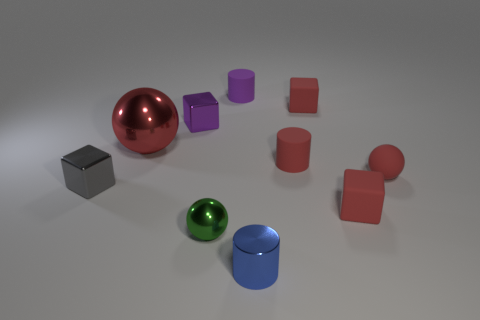How big is the green shiny thing that is on the left side of the rubber object in front of the small gray block?
Offer a very short reply. Small. There is a thing that is on the right side of the small rubber cube in front of the matte cube that is behind the red shiny sphere; what is its size?
Your response must be concise. Small. There is a tiny red thing that is in front of the small gray metallic block; is its shape the same as the rubber object left of the blue metallic thing?
Offer a terse response. No. What number of other things are the same color as the rubber ball?
Make the answer very short. 4. Is the size of the red object in front of the gray metal thing the same as the big shiny ball?
Ensure brevity in your answer.  No. Are the cylinder in front of the small green ball and the big red object that is behind the tiny blue shiny cylinder made of the same material?
Offer a very short reply. Yes. Are there any blue metallic objects that have the same size as the purple shiny object?
Offer a very short reply. Yes. What is the shape of the red rubber thing right of the small rubber block in front of the small metal cube that is behind the large object?
Your answer should be compact. Sphere. Are there more small blue cylinders that are on the left side of the small gray block than red things?
Your answer should be compact. No. Is there a big gray object that has the same shape as the green metal thing?
Provide a succinct answer. No. 